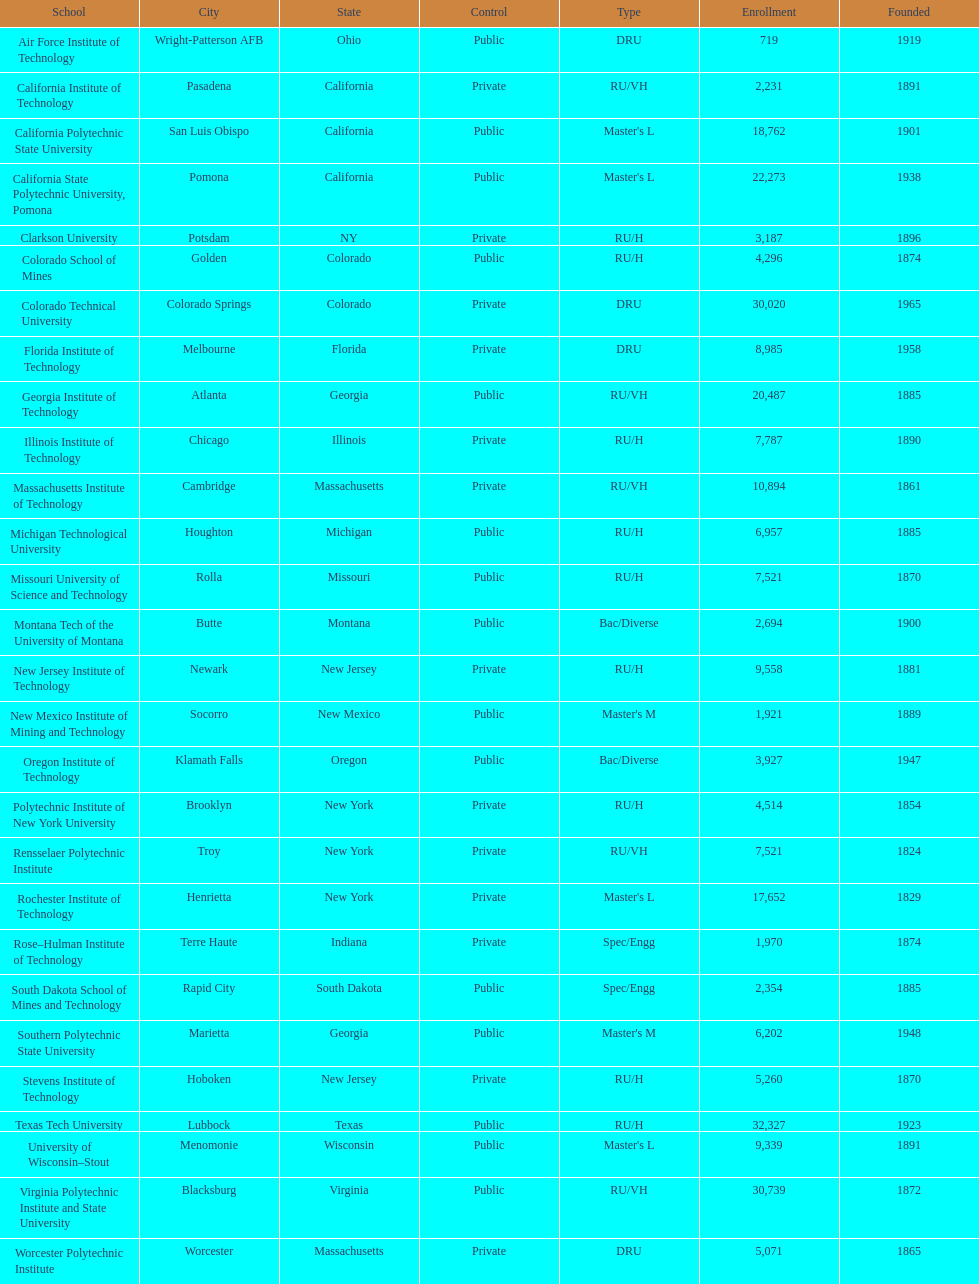Which us technological university has the top enrollment numbers? Texas Tech University. 